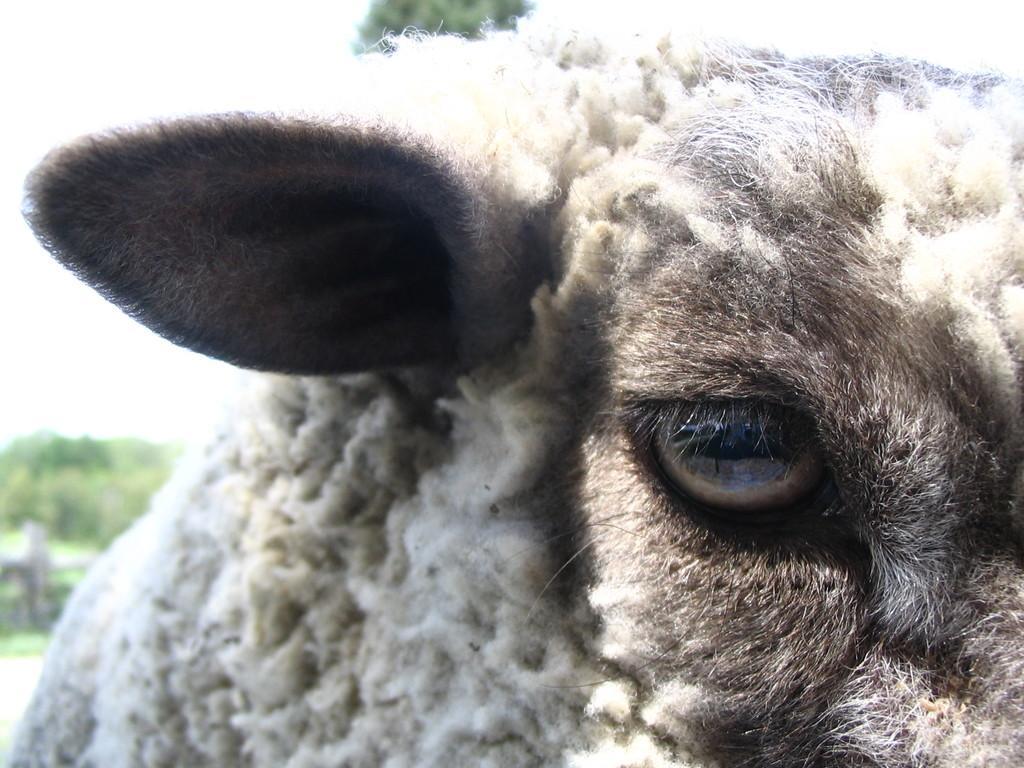Please provide a concise description of this image. As we can see in the image in the front there is a white color sheep and in the background there are trees. 